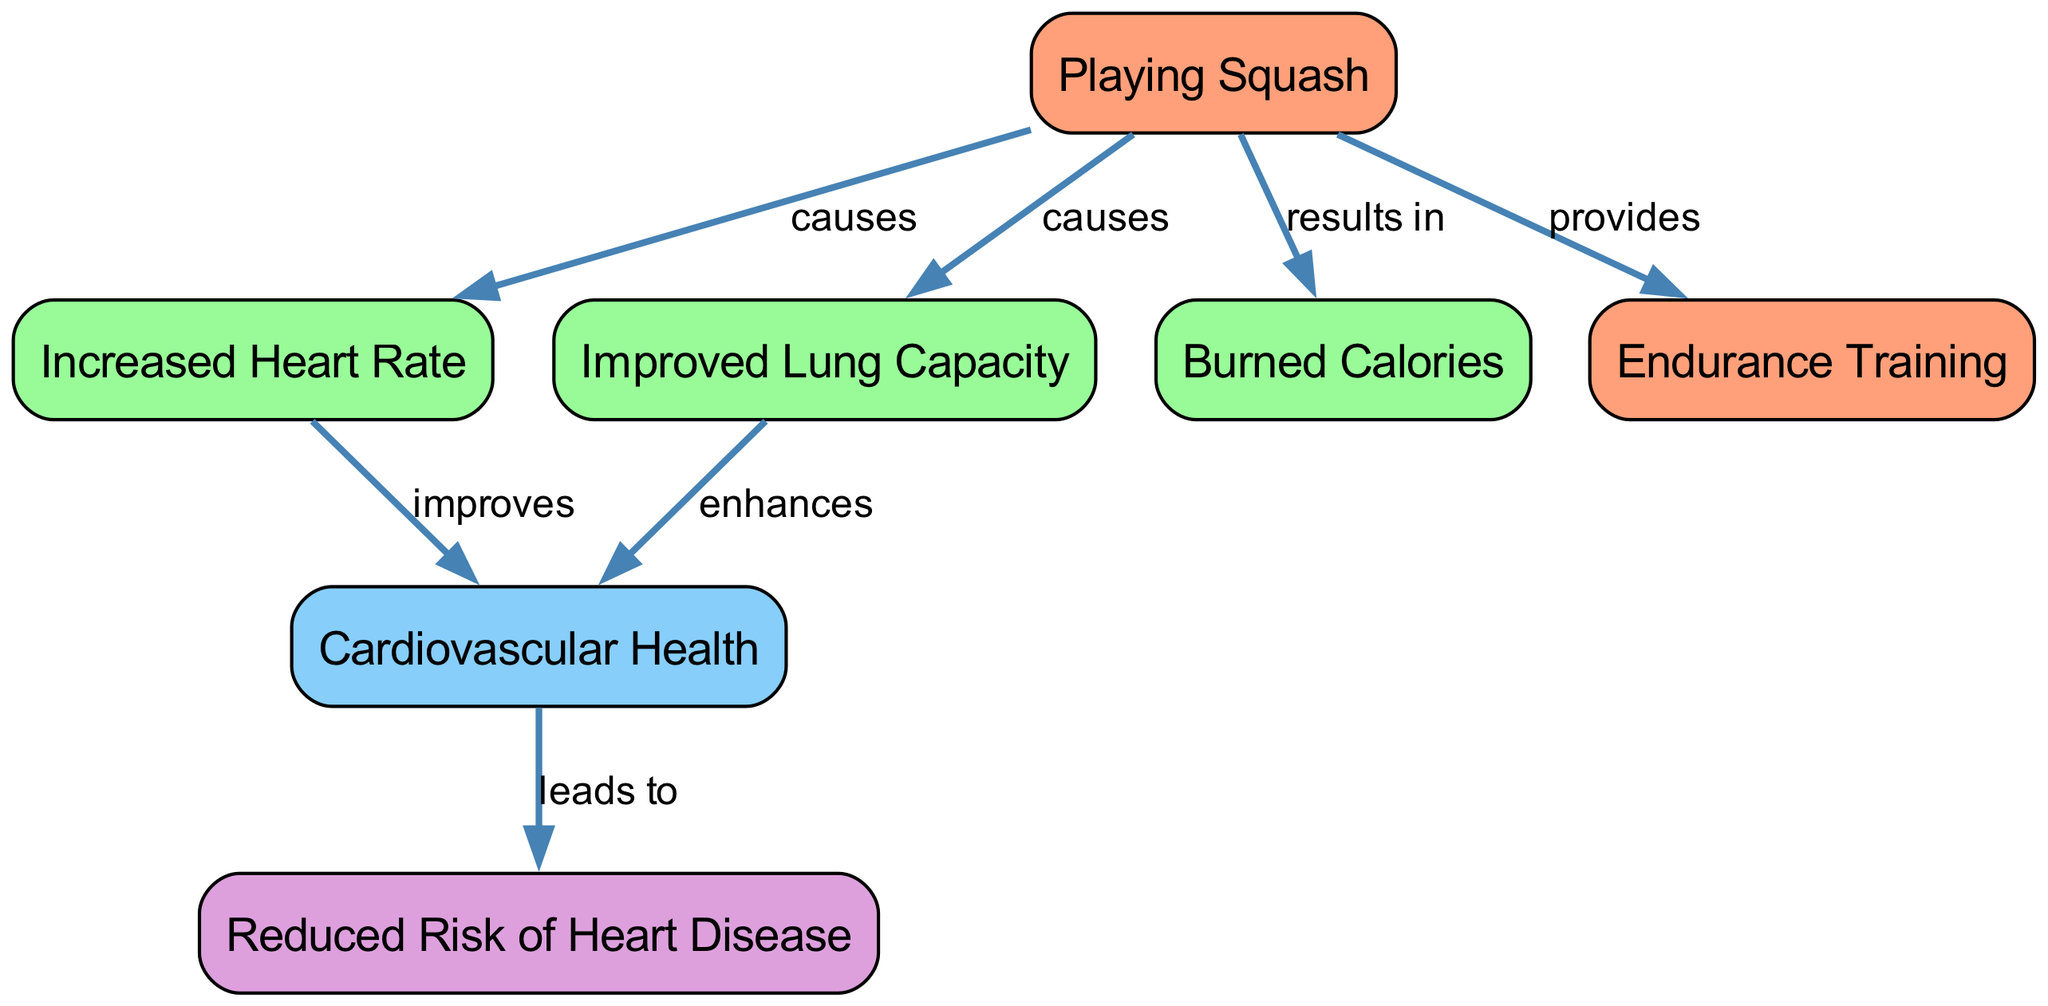What is the main activity that leads to cardiovascular benefits according to the diagram? The diagram identifies "Playing Squash" as the primary activity that is linked to several cardiovascular benefits. It is depicted as a process that causes effects like increased heart rate and improved lung capacity.
Answer: Playing Squash How many effects are listed in the diagram? The diagram shows a total of five effects resulting from playing squash. These effects are increased heart rate, improved lung capacity, burned calories, and the results from endurance training leading to cardiovascular health.
Answer: Five What does increased heart rate improve according to the diagram? The diagram indicates that increased heart rate improves cardiovascular health. This means that as one's heart rate increases due to playing squash, it positively impacts overall heart health.
Answer: Cardiovascular Health What outcome is linked to cardiovascular health in the diagram? The diagram specifies that reduced risk of heart disease is the outcome that results from improved cardiovascular health. This relationship illustrates the importance of maintaining good cardiovascular health to prevent heart diseases.
Answer: Reduced Risk of Heart Disease What process does playing squash provide to enhance performance? According to the diagram, playing squash provides endurance training, which is essential for building stamina and improving overall physical performance while playing.
Answer: Endurance Training How does improved lung capacity relate to cardiovascular health in the diagram? The diagram states that improved lung capacity enhances cardiovascular health, indicating that better lung function contributes to the efficiency and effectiveness of the cardiovascular system.
Answer: Enhances 